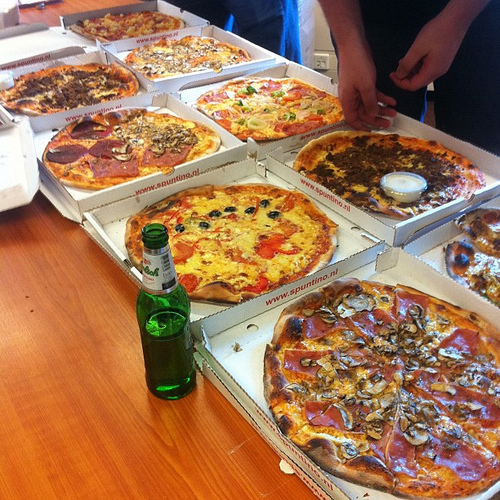What color does the cheese in the container have? The cheese in the container has a blue color. 